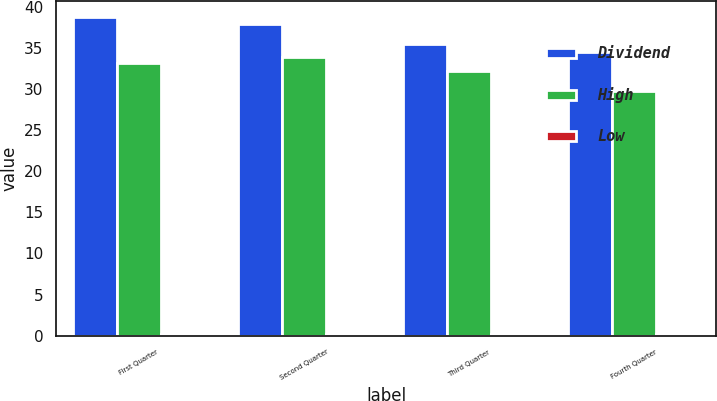<chart> <loc_0><loc_0><loc_500><loc_500><stacked_bar_chart><ecel><fcel>First Quarter<fcel>Second Quarter<fcel>Third Quarter<fcel>Fourth Quarter<nl><fcel>Dividend<fcel>38.84<fcel>37.96<fcel>35.48<fcel>34.53<nl><fcel>High<fcel>33.18<fcel>33.97<fcel>32.26<fcel>29.75<nl><fcel>Low<fcel>0.17<fcel>0.17<fcel>0.17<fcel>0.17<nl></chart> 